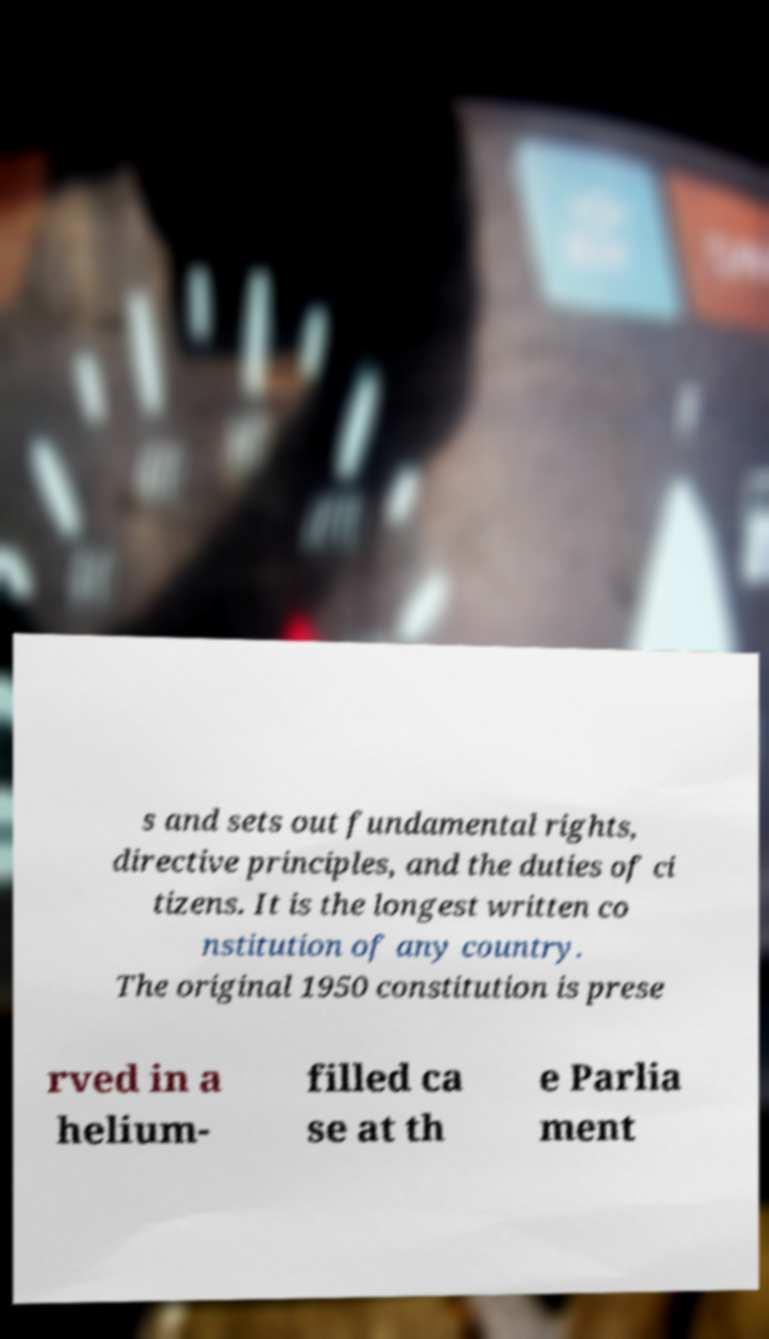Can you read and provide the text displayed in the image?This photo seems to have some interesting text. Can you extract and type it out for me? s and sets out fundamental rights, directive principles, and the duties of ci tizens. It is the longest written co nstitution of any country. The original 1950 constitution is prese rved in a helium- filled ca se at th e Parlia ment 